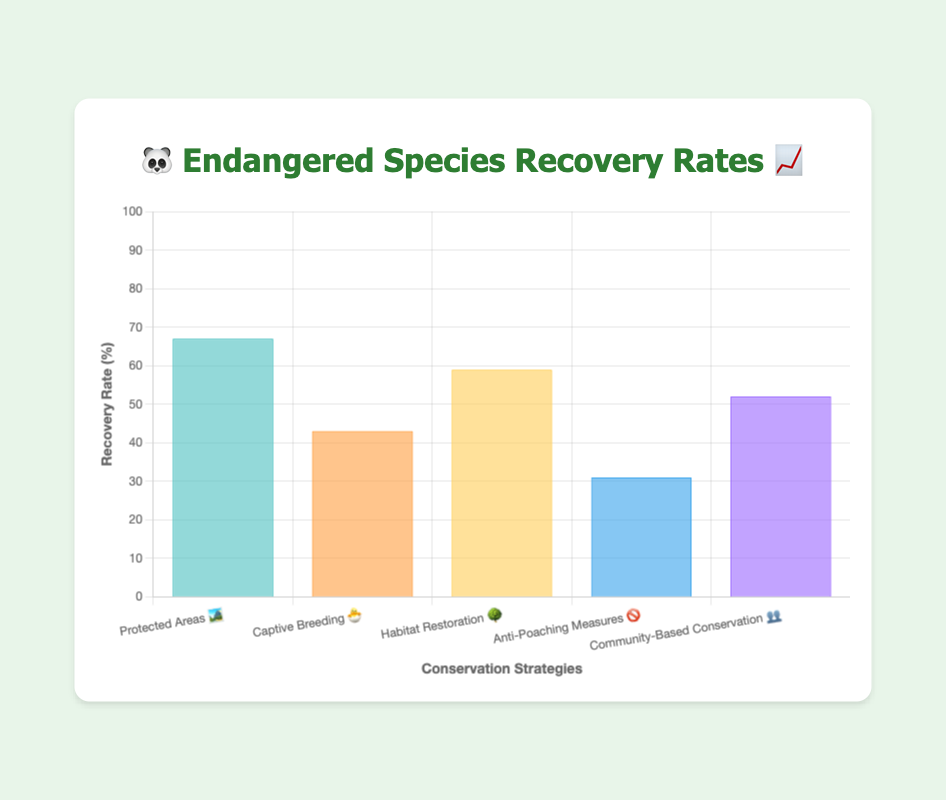What's the title of the chart? The title is usually placed at the top of the chart, larger in font size compared to axis labels. The title here reads "🐼 Endangered Species Recovery Rates 📈".
Answer: 🐼 Endangered Species Recovery Rates 📈 What does the y-axis represent? The y-axis title indicates what data is being measured. In this chart, it is labeled "Recovery Rate (%)", hence it represents the recovery rates of species in percentage.
Answer: Recovery Rate (%) Which conservation strategy has the highest recovery rate? To find the highest recovery rate, check the bar with the greatest height. The strategy “Protected Areas 🏞️” has the highest recovery rate of 67%.
Answer: Protected Areas 🏞️ What's the recovery rate for Anti-Poaching Measures? Locate the bar labeled "Anti-Poaching Measures 🚫" and read its corresponding value on the y-axis. It is 31%.
Answer: 31% How many different conservation strategies are compared in the chart? Count the number of bars or labels on the x-axis, each representing a different conservation strategy. There are 5 strategies.
Answer: 5 Which conservation strategy has the lowest recovery rate, and what is the rate? Identify the shortest bar which corresponds to the lowest recovery rate. The Anti-Poaching Measures 🚫 has the lowest recovery rate of 31%.
Answer: Anti-Poaching Measures 🚫, 31% What’s the difference in recovery rates between the highest and lowest strategies? Subtract the lowest recovery rate from the highest. The highest rate is 67% (Protected Areas 🏞️) and the lowest is 31% (Anti-Poaching Measures 🚫). Calculation: 67 - 31 = 36.
Answer: 36% What is the average recovery rate across all conservation strategies? Add up all recovery rates and divide by the number of strategies. (67 + 43 + 59 + 31 + 52) / 5 = 50.4.
Answer: 50.4 Which conservation strategy has a recovery rate closest to the average rate? Calculate the absolute difference between each strategy's recovery rate and the average (50.4). Protected Areas (67), Captive Breeding (43), Habitat Restoration (59), Anti-Poaching (31), Community-Based Conservation (52). The closest values are 52 and 50.4 (Community-Based Conservation 👥).
Answer: Community-Based Conservation 👥 What color represents the "Habitat Restoration 🌳" strategy in the chart? The color representing each strategy can be seen in the legend or by looking at the color of each bar. Habitat Restoration 🌳 is represented by a yellowish color.
Answer: Yellowish 